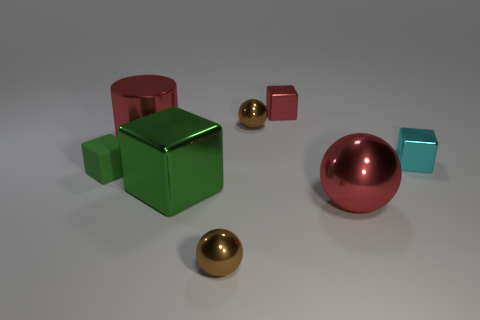Add 2 big cubes. How many objects exist? 10 Subtract all spheres. How many objects are left? 5 Subtract all large metallic blocks. Subtract all green matte balls. How many objects are left? 7 Add 8 red cylinders. How many red cylinders are left? 9 Add 7 brown metallic spheres. How many brown metallic spheres exist? 9 Subtract 0 purple cylinders. How many objects are left? 8 